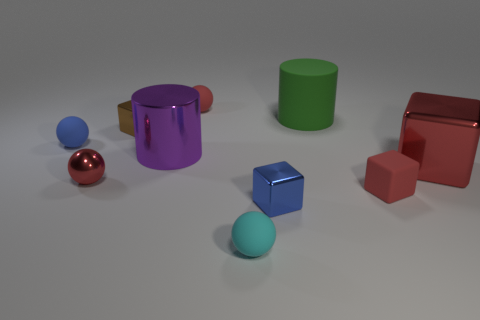Imagine this is a still from a child's game, what might the rules be involving these shapes? In this imagined children's game, each shape could represent a different character or element in a magical world. The rule might be to 'balance the elements' by ensuring that each color has a representation in both the sphere and cube forms, puzzling together the correct pieces. Or, it could involve a memory component, where players must recall the position and color of shapes after they've been briefly shown and then hidden or scrambled. 